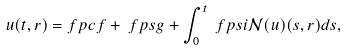<formula> <loc_0><loc_0><loc_500><loc_500>u ( t , r ) = & \ f p c f + \ f p s g + \int _ { 0 } ^ { t } \ f p s i \mathcal { N } ( u ) ( s , r ) d s ,</formula> 